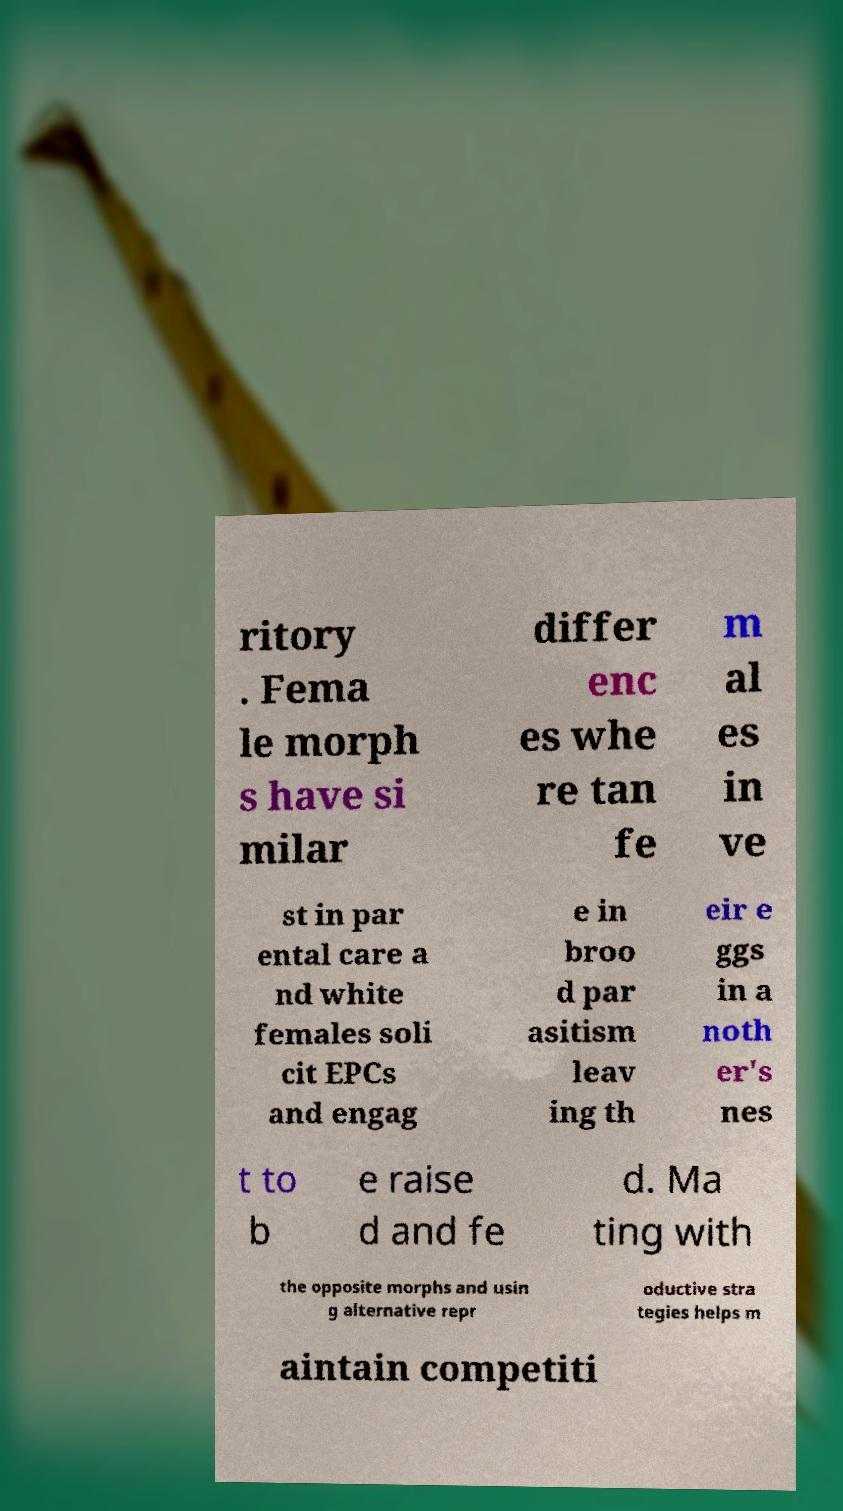Please read and relay the text visible in this image. What does it say? ritory . Fema le morph s have si milar differ enc es whe re tan fe m al es in ve st in par ental care a nd white females soli cit EPCs and engag e in broo d par asitism leav ing th eir e ggs in a noth er's nes t to b e raise d and fe d. Ma ting with the opposite morphs and usin g alternative repr oductive stra tegies helps m aintain competiti 